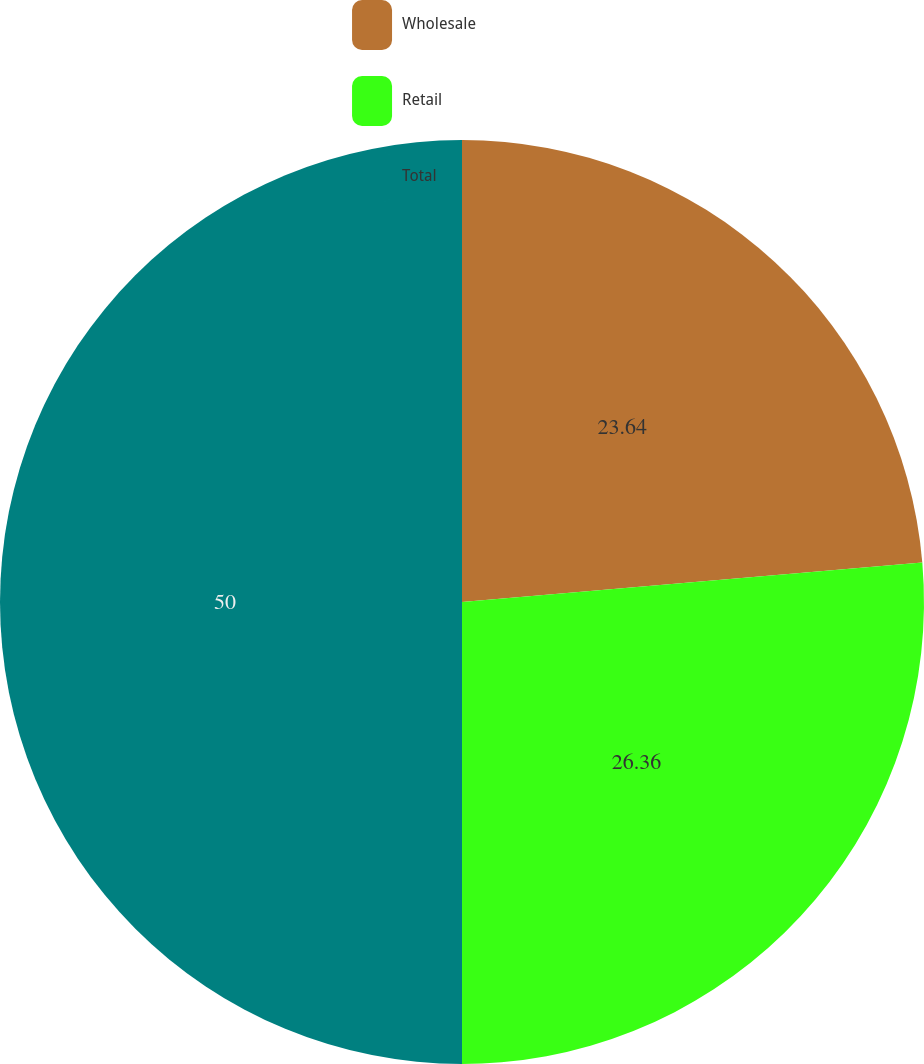<chart> <loc_0><loc_0><loc_500><loc_500><pie_chart><fcel>Wholesale<fcel>Retail<fcel>Total<nl><fcel>23.64%<fcel>26.36%<fcel>50.0%<nl></chart> 